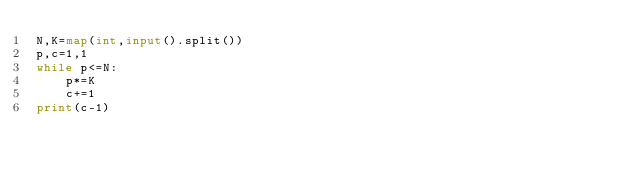Convert code to text. <code><loc_0><loc_0><loc_500><loc_500><_Python_>N,K=map(int,input().split())
p,c=1,1
while p<=N:
    p*=K
    c+=1
print(c-1)</code> 